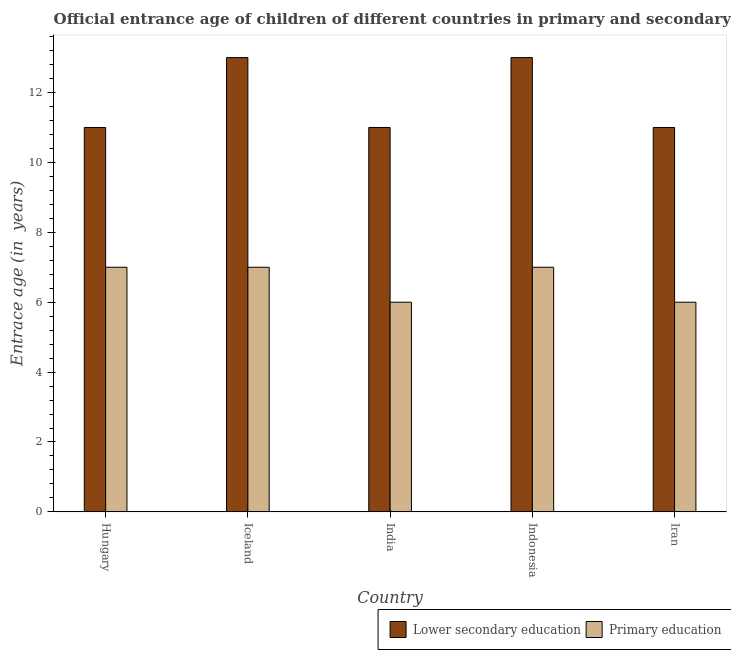How many different coloured bars are there?
Your response must be concise. 2. How many groups of bars are there?
Offer a very short reply. 5. Are the number of bars per tick equal to the number of legend labels?
Make the answer very short. Yes. Are the number of bars on each tick of the X-axis equal?
Give a very brief answer. Yes. How many bars are there on the 2nd tick from the left?
Keep it short and to the point. 2. What is the label of the 3rd group of bars from the left?
Offer a very short reply. India. What is the entrance age of children in lower secondary education in Hungary?
Provide a succinct answer. 11. Across all countries, what is the maximum entrance age of children in lower secondary education?
Your response must be concise. 13. Across all countries, what is the minimum entrance age of children in lower secondary education?
Your answer should be compact. 11. In which country was the entrance age of chiildren in primary education maximum?
Your answer should be compact. Hungary. In which country was the entrance age of children in lower secondary education minimum?
Offer a terse response. Hungary. What is the total entrance age of children in lower secondary education in the graph?
Provide a succinct answer. 59. What is the difference between the entrance age of children in lower secondary education in Iceland and that in Indonesia?
Give a very brief answer. 0. What is the difference between the entrance age of chiildren in primary education in Iran and the entrance age of children in lower secondary education in India?
Give a very brief answer. -5. What is the average entrance age of children in lower secondary education per country?
Your answer should be compact. 11.8. What is the difference between the entrance age of chiildren in primary education and entrance age of children in lower secondary education in Iceland?
Offer a very short reply. -6. What is the ratio of the entrance age of chiildren in primary education in Hungary to that in India?
Keep it short and to the point. 1.17. Is the entrance age of chiildren in primary education in Iceland less than that in Indonesia?
Offer a terse response. No. What is the difference between the highest and the lowest entrance age of children in lower secondary education?
Make the answer very short. 2. In how many countries, is the entrance age of children in lower secondary education greater than the average entrance age of children in lower secondary education taken over all countries?
Offer a very short reply. 2. Is the sum of the entrance age of chiildren in primary education in India and Iran greater than the maximum entrance age of children in lower secondary education across all countries?
Ensure brevity in your answer.  No. What does the 1st bar from the left in Indonesia represents?
Give a very brief answer. Lower secondary education. What does the 1st bar from the right in Indonesia represents?
Ensure brevity in your answer.  Primary education. Are all the bars in the graph horizontal?
Offer a very short reply. No. How many countries are there in the graph?
Offer a terse response. 5. Does the graph contain grids?
Ensure brevity in your answer.  No. Where does the legend appear in the graph?
Ensure brevity in your answer.  Bottom right. How are the legend labels stacked?
Provide a succinct answer. Horizontal. What is the title of the graph?
Ensure brevity in your answer.  Official entrance age of children of different countries in primary and secondary education. Does "Attending school" appear as one of the legend labels in the graph?
Offer a terse response. No. What is the label or title of the Y-axis?
Your answer should be very brief. Entrace age (in  years). What is the Entrace age (in  years) in Lower secondary education in Iceland?
Keep it short and to the point. 13. What is the Entrace age (in  years) of Primary education in India?
Provide a short and direct response. 6. What is the Entrace age (in  years) of Lower secondary education in Iran?
Your answer should be very brief. 11. What is the Entrace age (in  years) of Primary education in Iran?
Give a very brief answer. 6. Across all countries, what is the maximum Entrace age (in  years) in Lower secondary education?
Provide a succinct answer. 13. Across all countries, what is the maximum Entrace age (in  years) in Primary education?
Keep it short and to the point. 7. Across all countries, what is the minimum Entrace age (in  years) in Lower secondary education?
Provide a succinct answer. 11. What is the difference between the Entrace age (in  years) of Lower secondary education in Hungary and that in Iceland?
Offer a terse response. -2. What is the difference between the Entrace age (in  years) in Lower secondary education in Hungary and that in India?
Your answer should be compact. 0. What is the difference between the Entrace age (in  years) of Primary education in Hungary and that in India?
Provide a short and direct response. 1. What is the difference between the Entrace age (in  years) of Lower secondary education in Iceland and that in India?
Give a very brief answer. 2. What is the difference between the Entrace age (in  years) in Primary education in Iceland and that in Indonesia?
Provide a short and direct response. 0. What is the difference between the Entrace age (in  years) of Primary education in Iceland and that in Iran?
Provide a short and direct response. 1. What is the difference between the Entrace age (in  years) of Primary education in India and that in Indonesia?
Make the answer very short. -1. What is the difference between the Entrace age (in  years) in Lower secondary education in India and that in Iran?
Provide a short and direct response. 0. What is the difference between the Entrace age (in  years) of Primary education in India and that in Iran?
Provide a short and direct response. 0. What is the difference between the Entrace age (in  years) of Lower secondary education in Hungary and the Entrace age (in  years) of Primary education in Indonesia?
Provide a succinct answer. 4. What is the difference between the Entrace age (in  years) in Lower secondary education in Hungary and the Entrace age (in  years) in Primary education in Iran?
Ensure brevity in your answer.  5. What is the difference between the Entrace age (in  years) in Lower secondary education in Iceland and the Entrace age (in  years) in Primary education in India?
Your answer should be very brief. 7. What is the difference between the Entrace age (in  years) of Lower secondary education in Iceland and the Entrace age (in  years) of Primary education in Indonesia?
Ensure brevity in your answer.  6. What is the difference between the Entrace age (in  years) of Lower secondary education in India and the Entrace age (in  years) of Primary education in Iran?
Your answer should be compact. 5. What is the average Entrace age (in  years) in Primary education per country?
Provide a succinct answer. 6.6. What is the difference between the Entrace age (in  years) in Lower secondary education and Entrace age (in  years) in Primary education in Hungary?
Give a very brief answer. 4. What is the difference between the Entrace age (in  years) in Lower secondary education and Entrace age (in  years) in Primary education in Iceland?
Your response must be concise. 6. What is the difference between the Entrace age (in  years) in Lower secondary education and Entrace age (in  years) in Primary education in India?
Offer a terse response. 5. What is the ratio of the Entrace age (in  years) in Lower secondary education in Hungary to that in Iceland?
Offer a very short reply. 0.85. What is the ratio of the Entrace age (in  years) of Primary education in Hungary to that in Iceland?
Offer a terse response. 1. What is the ratio of the Entrace age (in  years) in Lower secondary education in Hungary to that in India?
Provide a succinct answer. 1. What is the ratio of the Entrace age (in  years) in Lower secondary education in Hungary to that in Indonesia?
Your answer should be very brief. 0.85. What is the ratio of the Entrace age (in  years) of Primary education in Hungary to that in Indonesia?
Offer a terse response. 1. What is the ratio of the Entrace age (in  years) of Lower secondary education in Hungary to that in Iran?
Give a very brief answer. 1. What is the ratio of the Entrace age (in  years) in Primary education in Hungary to that in Iran?
Ensure brevity in your answer.  1.17. What is the ratio of the Entrace age (in  years) of Lower secondary education in Iceland to that in India?
Ensure brevity in your answer.  1.18. What is the ratio of the Entrace age (in  years) of Primary education in Iceland to that in India?
Your response must be concise. 1.17. What is the ratio of the Entrace age (in  years) in Lower secondary education in Iceland to that in Iran?
Give a very brief answer. 1.18. What is the ratio of the Entrace age (in  years) of Lower secondary education in India to that in Indonesia?
Make the answer very short. 0.85. What is the ratio of the Entrace age (in  years) in Primary education in India to that in Indonesia?
Ensure brevity in your answer.  0.86. What is the ratio of the Entrace age (in  years) of Lower secondary education in Indonesia to that in Iran?
Give a very brief answer. 1.18. What is the difference between the highest and the second highest Entrace age (in  years) in Primary education?
Ensure brevity in your answer.  0. 